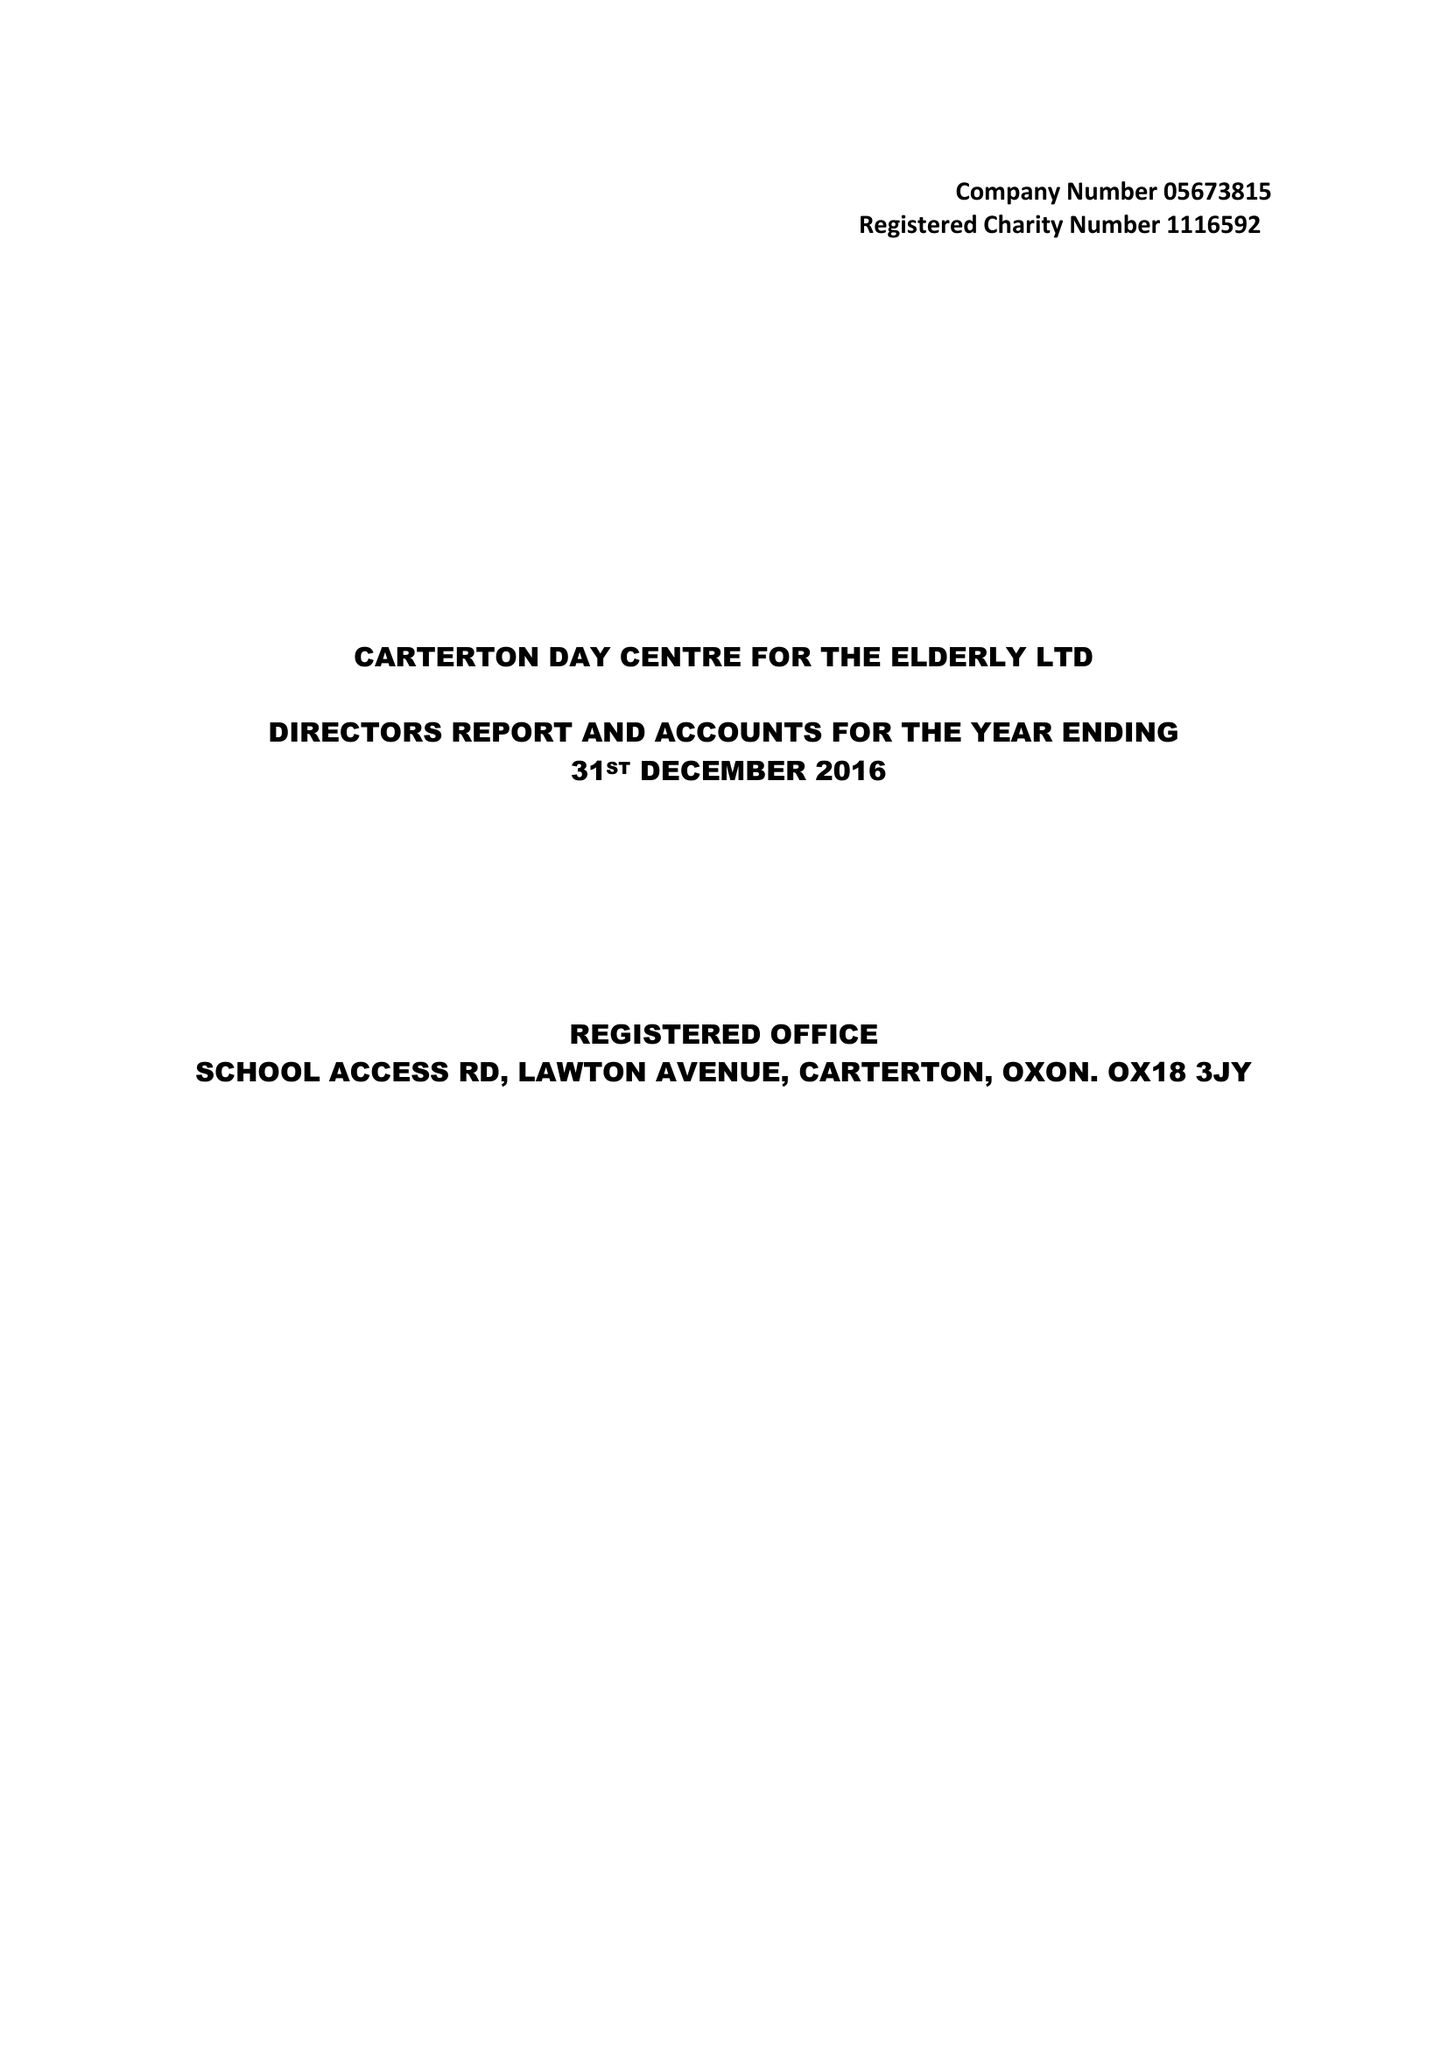What is the value for the charity_name?
Answer the question using a single word or phrase. Carterton Day Centre For The Elderly Ltd. 